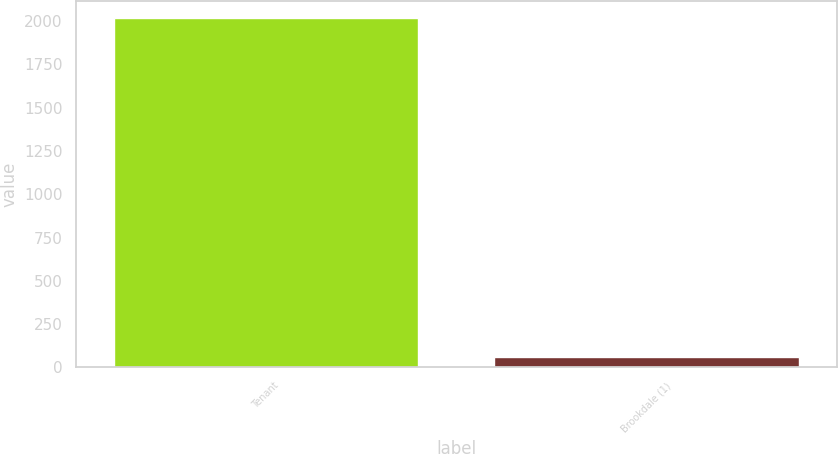Convert chart to OTSL. <chart><loc_0><loc_0><loc_500><loc_500><bar_chart><fcel>Tenant<fcel>Brookdale (1)<nl><fcel>2016<fcel>59<nl></chart> 